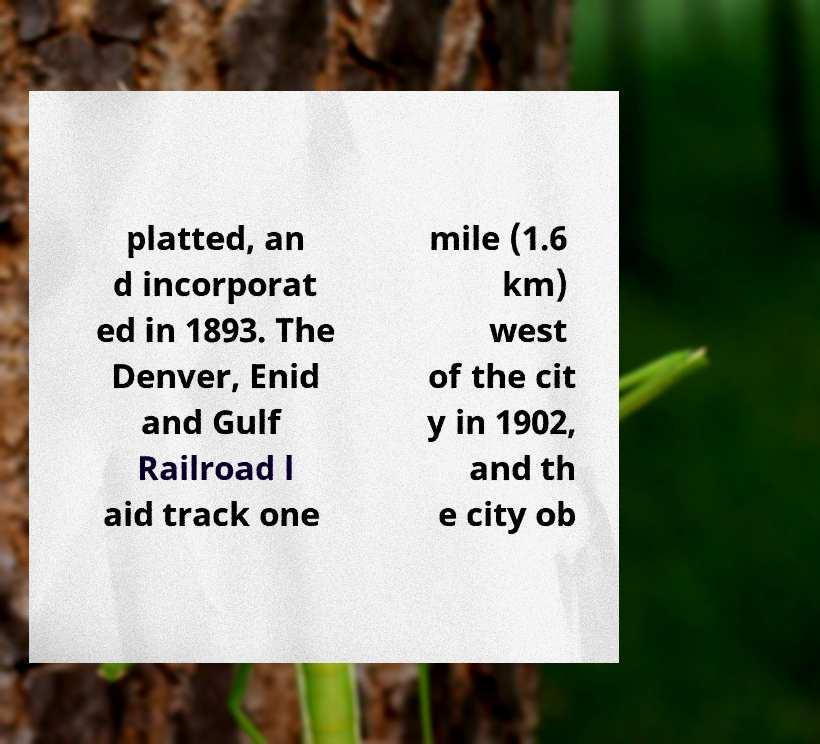Please identify and transcribe the text found in this image. platted, an d incorporat ed in 1893. The Denver, Enid and Gulf Railroad l aid track one mile (1.6 km) west of the cit y in 1902, and th e city ob 